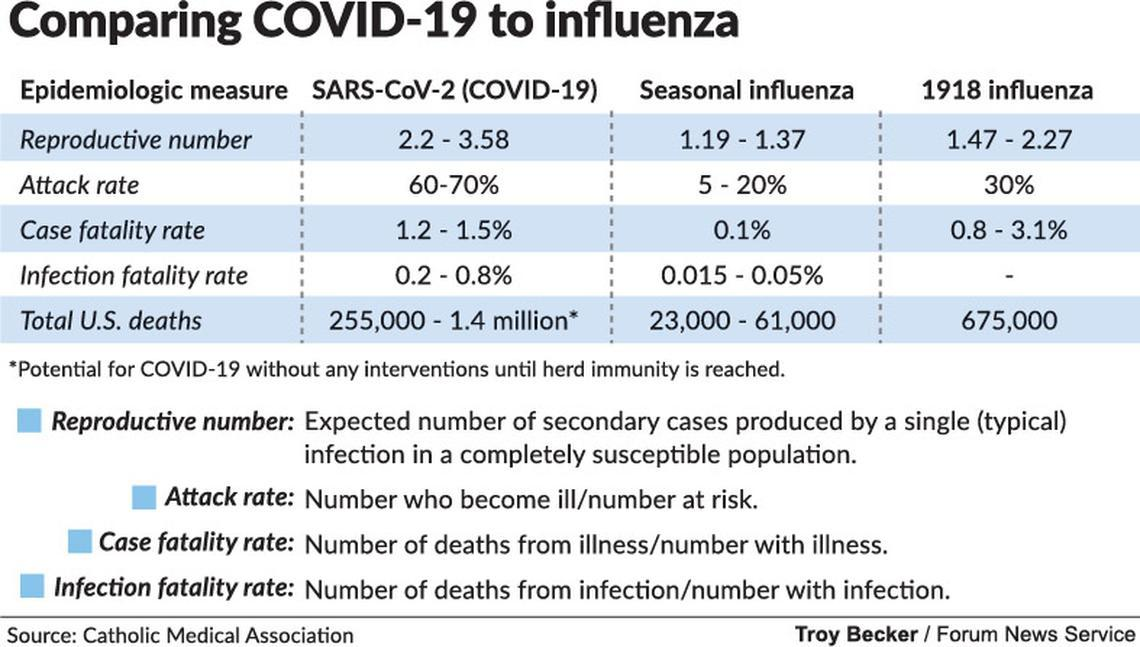Identify some key points in this picture. The attack rate of COVID-19 virus is estimated to be 60-70%. The infection fatality rate of seasonal influenza is estimated to be between 0.015 and 0.05% of the total number of cases. The total number of deaths in the United States caused by the 1918 influenza was approximately 675,000. According to recent estimates, the case fatality rate of seasonal influenza is approximately 0.1%. The total number of COVID-19 deaths in the United States is estimated to be between 255,000 and 1.4 million. 